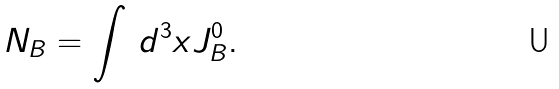<formula> <loc_0><loc_0><loc_500><loc_500>N _ { B } = \int \, d ^ { 3 } x J _ { B } ^ { 0 } .</formula> 